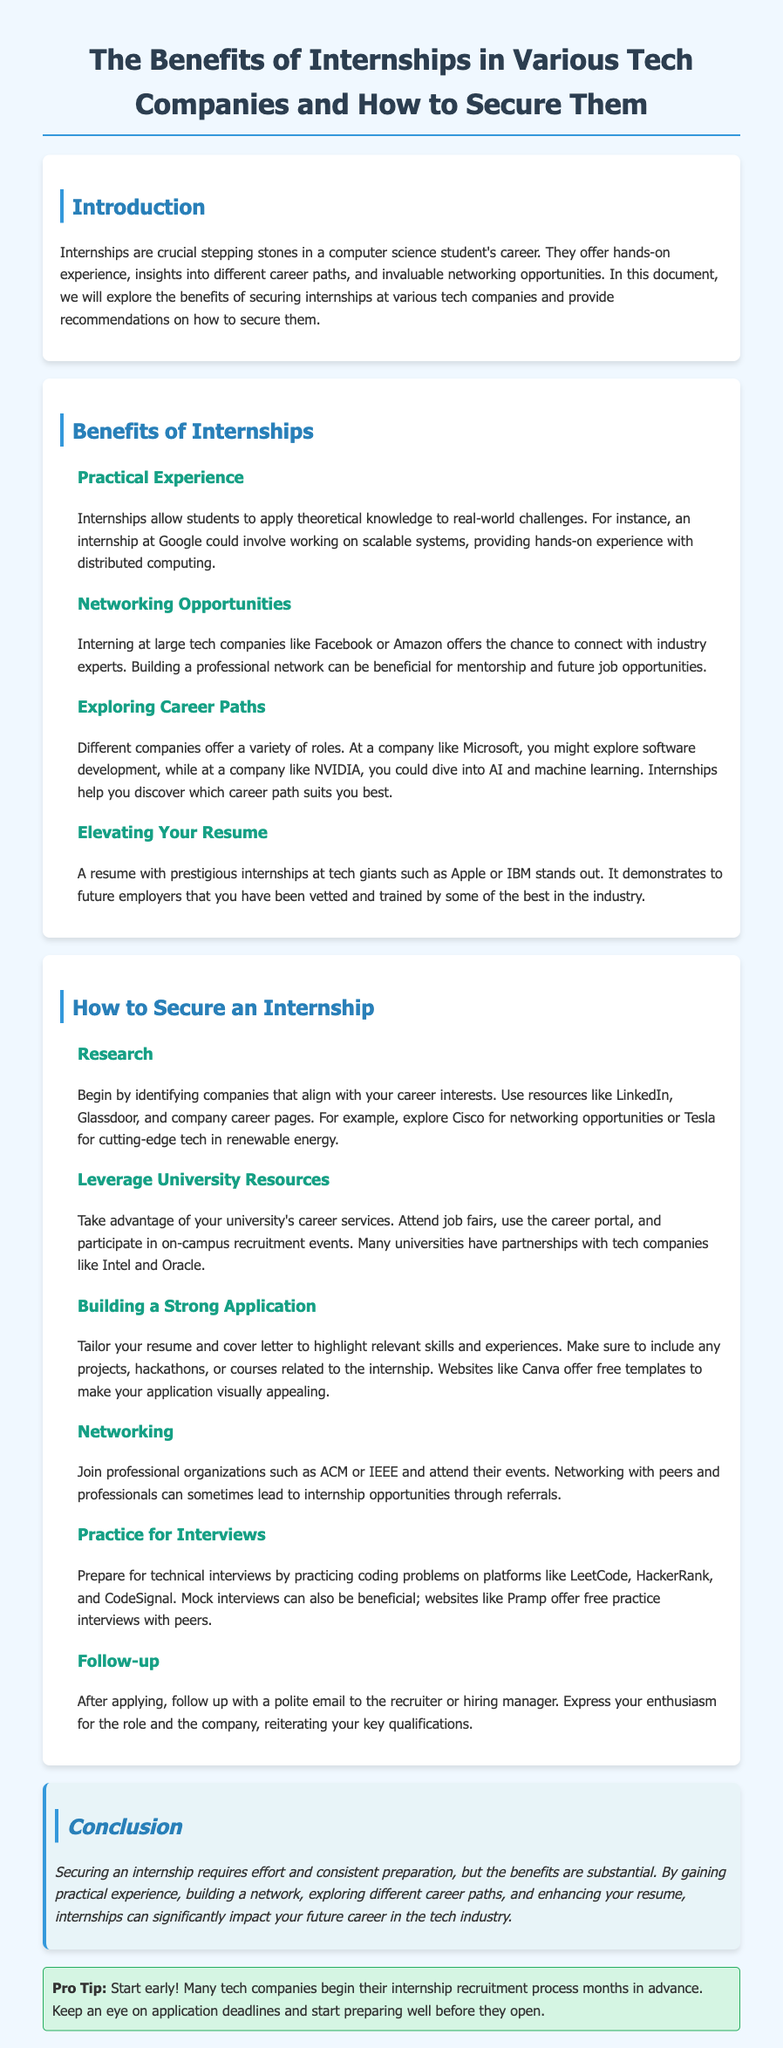What are internships crucial for? Internships are crucial stepping stones in a computer science student's career, offering hands-on experience, insights into different career paths, and invaluable networking opportunities.
Answer: Career development What is the benefit of internships at Google? An internship at Google could involve working on scalable systems, providing hands-on experience with distributed computing.
Answer: Practical Experience What should you do to find companies for internships? Identify companies that align with your career interests using resources like LinkedIn, Glassdoor, and company career pages.
Answer: Research Which professional organizations can help with networking? Joining professional organizations such as ACM or IEEE can help with networking.
Answer: ACM or IEEE What platform is recommended for technical interview practice? Platforms like LeetCode, HackerRank, and CodeSignal are recommended for technical interview practice.
Answer: LeetCode What is a good tip for internship applications? Start early! Many tech companies begin their internship recruitment process months in advance.
Answer: Start early How should you tailor your application materials? You should tailor your resume and cover letter to highlight relevant skills and experiences.
Answer: Tailor your application What is a key component of following up after an application? After applying, express your enthusiasm for the role and the company in a polite email.
Answer: Follow up 